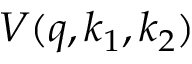Convert formula to latex. <formula><loc_0><loc_0><loc_500><loc_500>V ( q , k _ { 1 } , k _ { 2 } )</formula> 